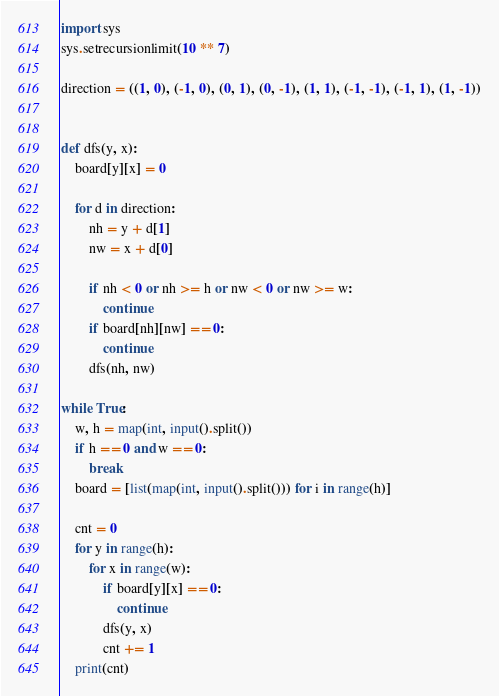<code> <loc_0><loc_0><loc_500><loc_500><_Python_>import sys
sys.setrecursionlimit(10 ** 7)

direction = ((1, 0), (-1, 0), (0, 1), (0, -1), (1, 1), (-1, -1), (-1, 1), (1, -1))


def dfs(y, x):
    board[y][x] = 0

    for d in direction:
        nh = y + d[1]
        nw = x + d[0]

        if nh < 0 or nh >= h or nw < 0 or nw >= w:
            continue
        if board[nh][nw] == 0:
            continue
        dfs(nh, nw)

while True:
    w, h = map(int, input().split())
    if h == 0 and w == 0:
        break
    board = [list(map(int, input().split())) for i in range(h)]

    cnt = 0
    for y in range(h):
        for x in range(w):
            if board[y][x] == 0:
                continue
            dfs(y, x)
            cnt += 1
    print(cnt)

</code> 